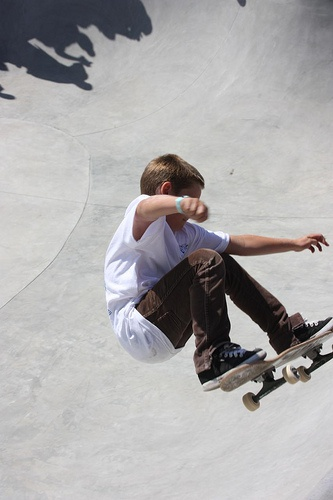Describe the objects in this image and their specific colors. I can see people in black, gray, darkgray, and lavender tones and skateboard in black, gray, lightgray, and darkgray tones in this image. 